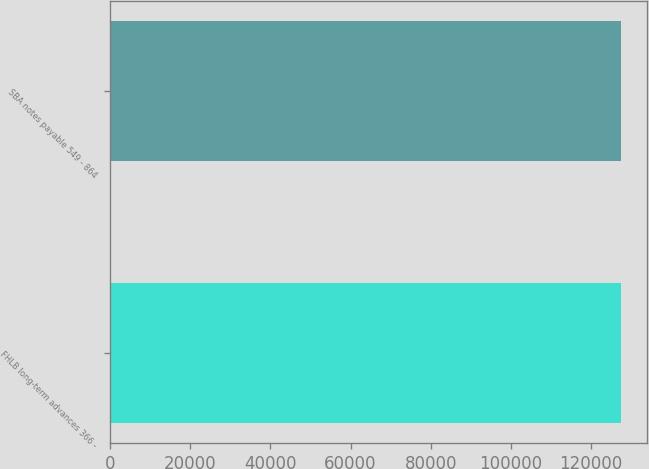<chart> <loc_0><loc_0><loc_500><loc_500><bar_chart><fcel>FHLB long-term advances 366 -<fcel>SBA notes payable 549 - 864<nl><fcel>127612<fcel>127612<nl></chart> 